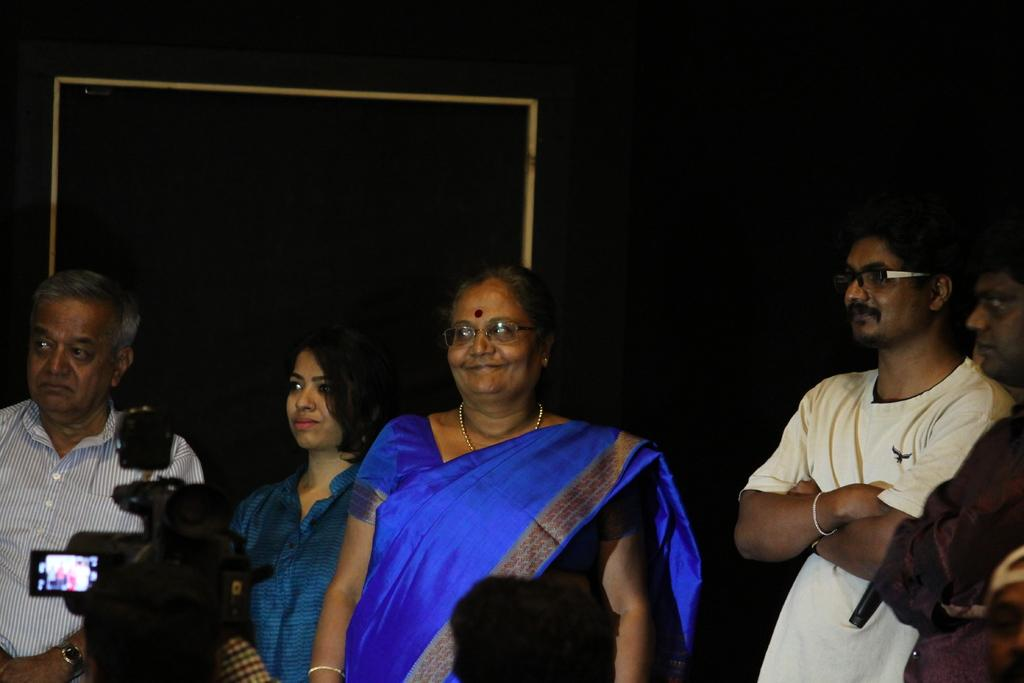How many people are in the image? There are persons in the image, but the exact number is not specified. What can be observed about the background of the image? The background of the image is dark. Can you identify any equipment in the image? Yes, there is a video camera in the bottom left of the image. What type of polish is being applied to the wheel in the image? There is no wheel or polish present in the image. Is this a birthday party scene, given the presence of persons in the image? The facts provided do not mention any birthday celebration, so we cannot assume it is a birthday party scene. 